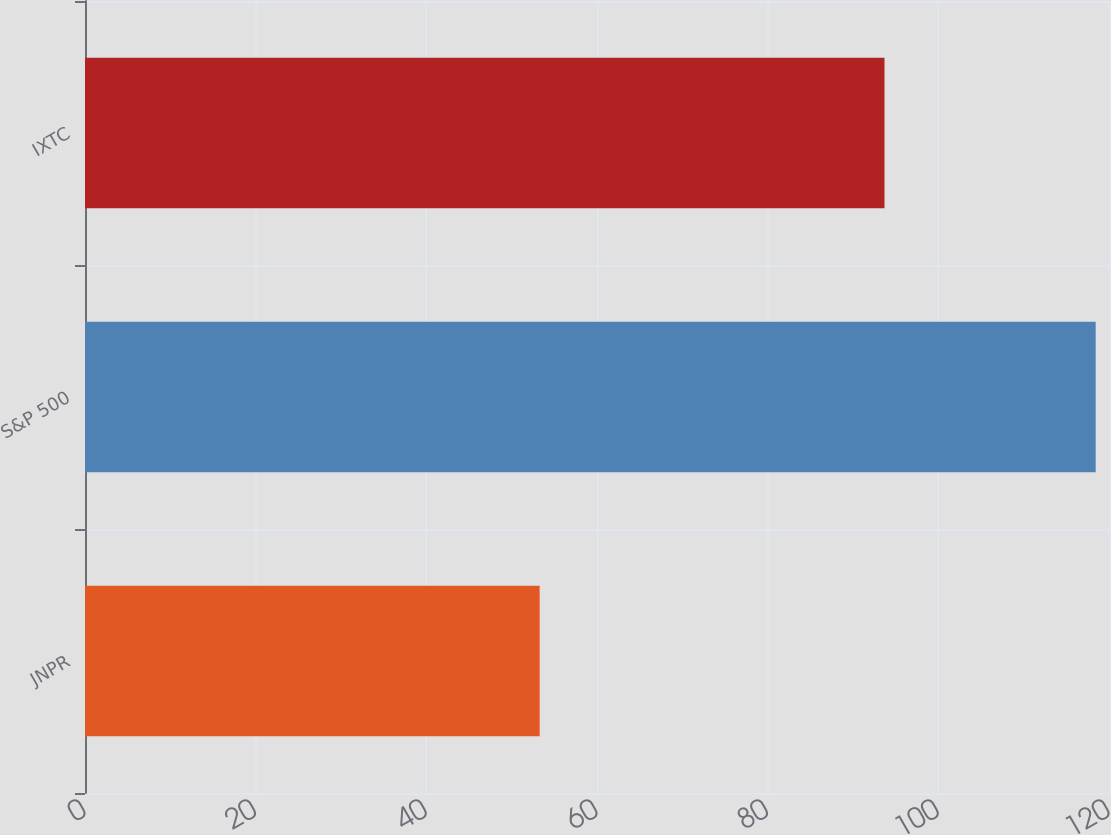Convert chart to OTSL. <chart><loc_0><loc_0><loc_500><loc_500><bar_chart><fcel>JNPR<fcel>S&P 500<fcel>IXTC<nl><fcel>53.28<fcel>118.44<fcel>93.69<nl></chart> 